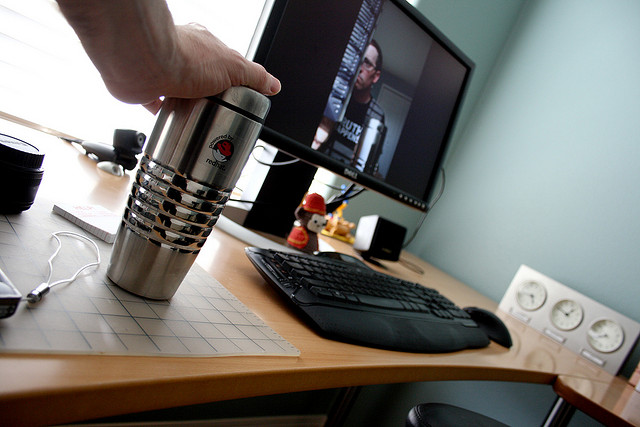Please identify all text content in this image. RUTF 